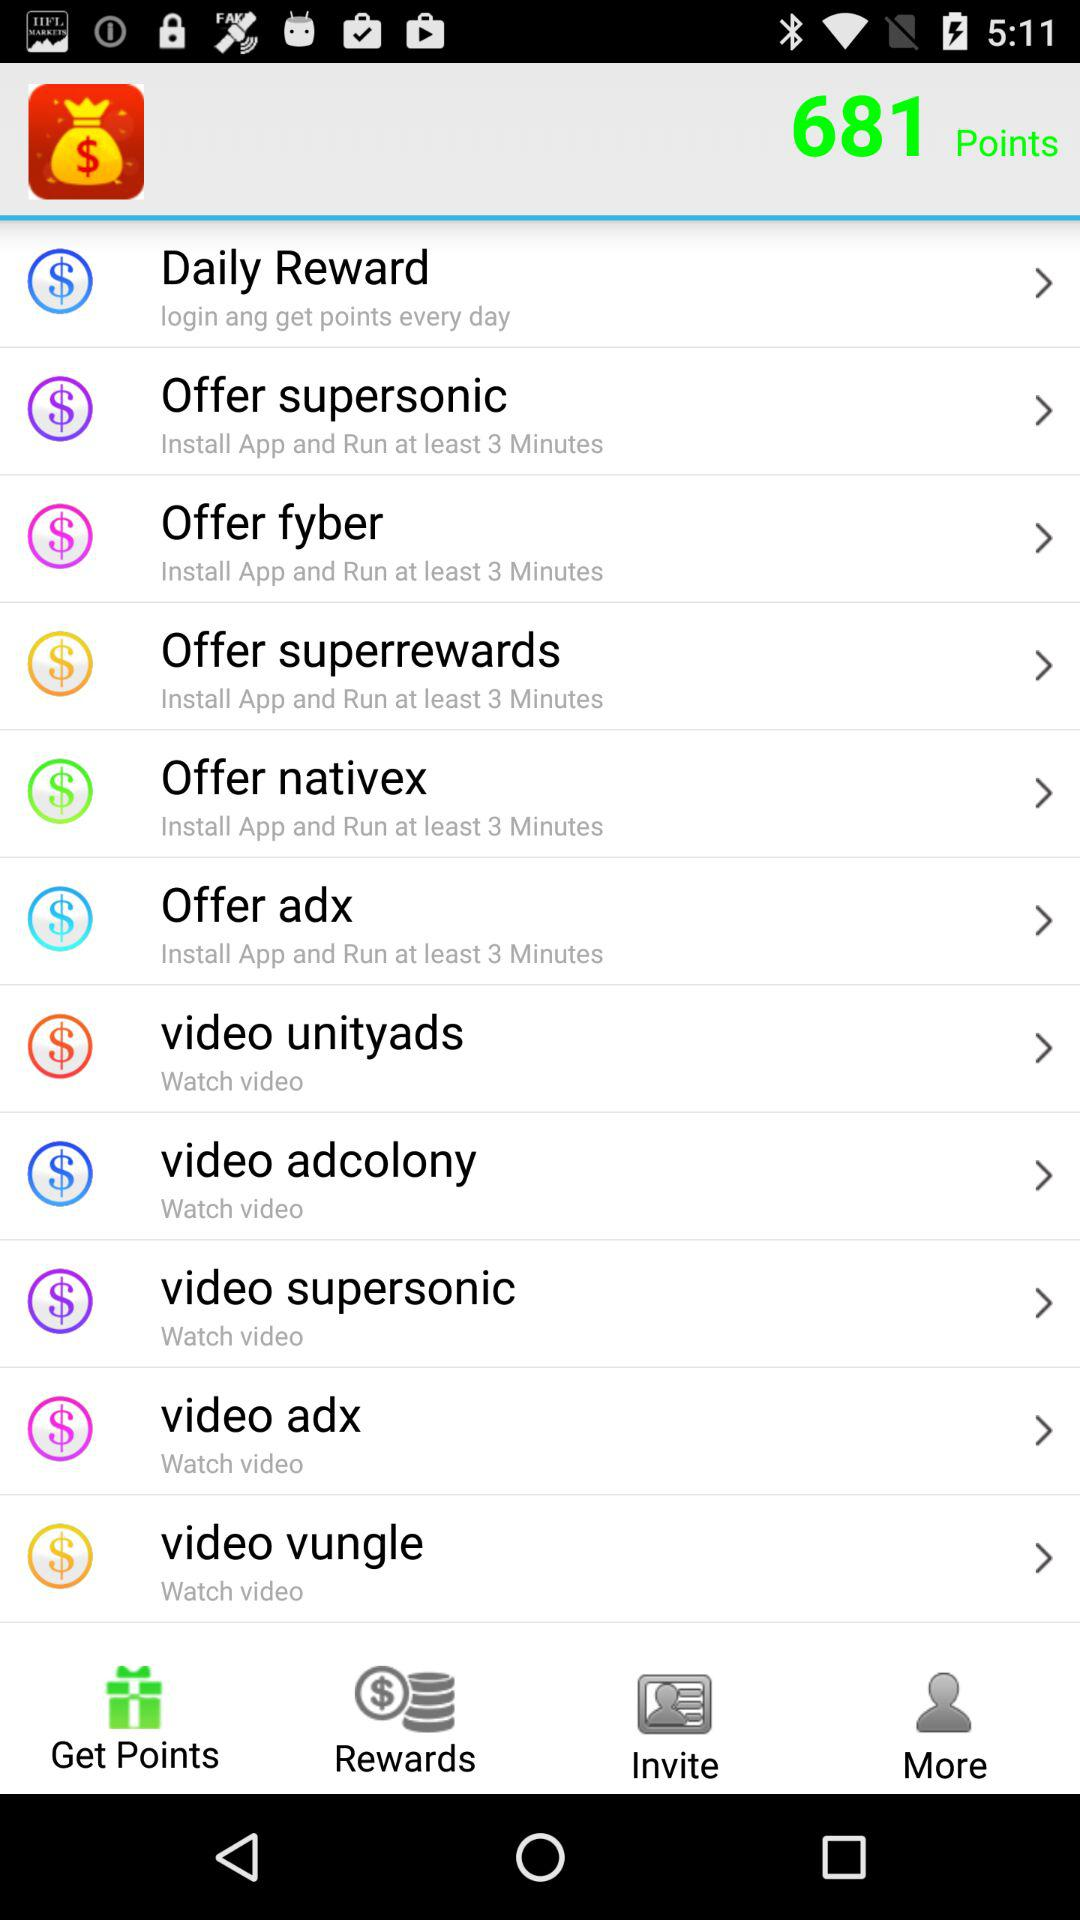What is the minimum time for which the application should run? The minimum time for which the application should run is 3 minutes. 